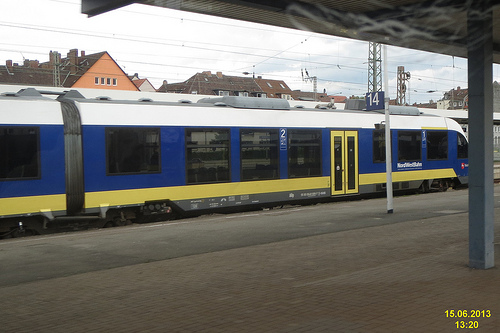Is there a fence or a train in this image? In this image, a train is clearly visible, stationed along the platform, but I cannot see a fence. 